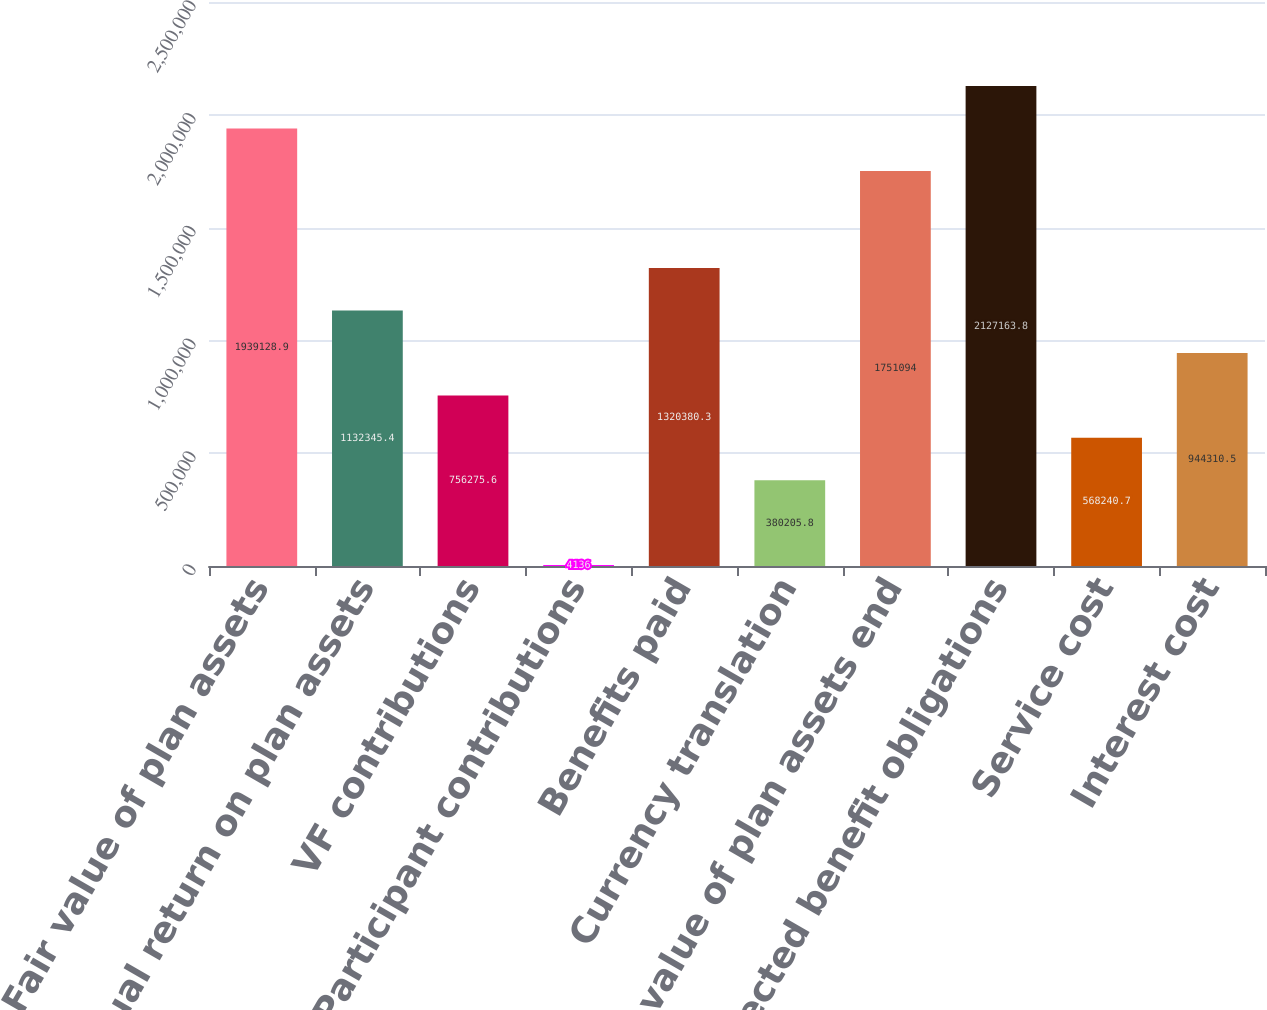Convert chart. <chart><loc_0><loc_0><loc_500><loc_500><bar_chart><fcel>Fair value of plan assets<fcel>Actual return on plan assets<fcel>VF contributions<fcel>Participant contributions<fcel>Benefits paid<fcel>Currency translation<fcel>Fair value of plan assets end<fcel>Projected benefit obligations<fcel>Service cost<fcel>Interest cost<nl><fcel>1.93913e+06<fcel>1.13235e+06<fcel>756276<fcel>4136<fcel>1.32038e+06<fcel>380206<fcel>1.75109e+06<fcel>2.12716e+06<fcel>568241<fcel>944310<nl></chart> 